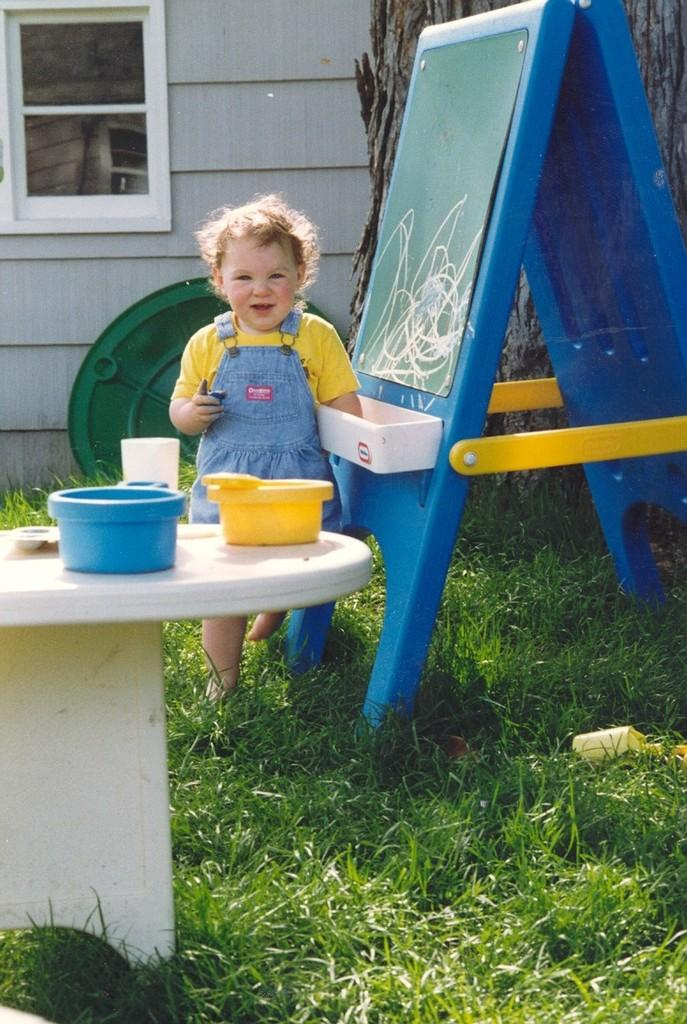Where was the image taken? The image is taken outdoors. What is the baby doing in the image? The baby is playing in the grass. What is in front of the baby? There is a table in front of the baby. What is on the table? There are bowls on the table. What is visible behind the baby? There is a window glass behind the baby. What committee is the baby a part of in the image? There is no committee present in the image; it features a baby playing in the grass. What thought is the baby having while playing in the image? It is impossible to determine the baby's thoughts from the image. 